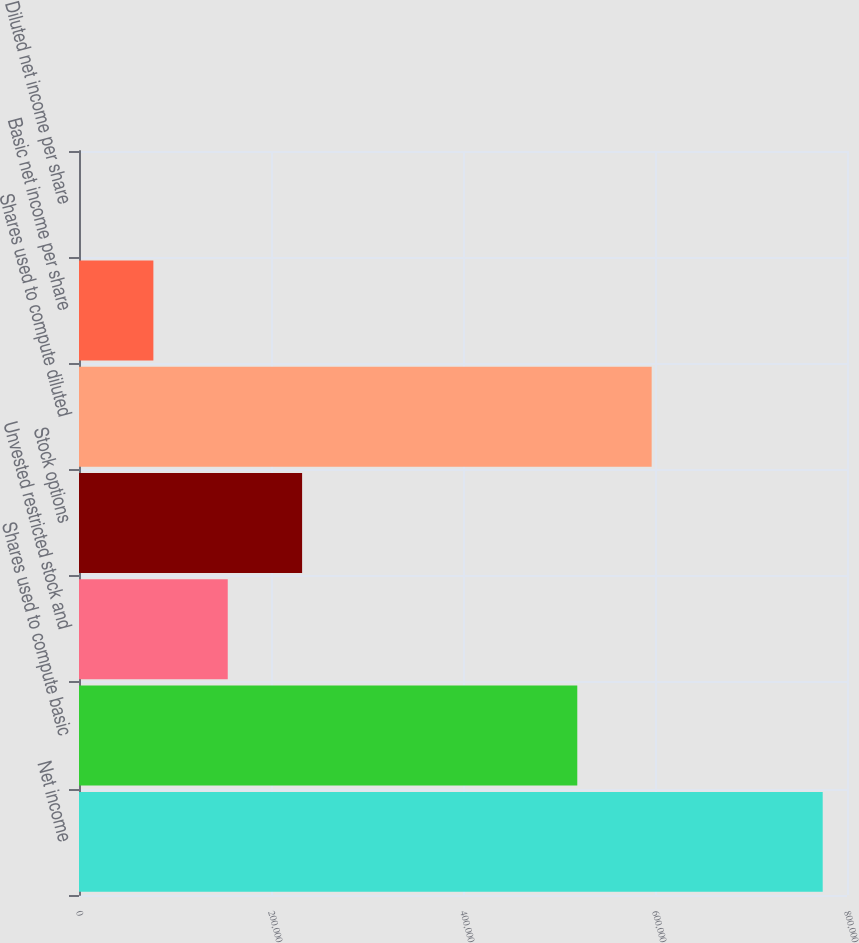<chart> <loc_0><loc_0><loc_500><loc_500><bar_chart><fcel>Net income<fcel>Shares used to compute basic<fcel>Unvested restricted stock and<fcel>Stock options<fcel>Shares used to compute diluted<fcel>Basic net income per share<fcel>Diluted net income per share<nl><fcel>774680<fcel>519045<fcel>154937<fcel>232405<fcel>596513<fcel>77469.3<fcel>1.47<nl></chart> 